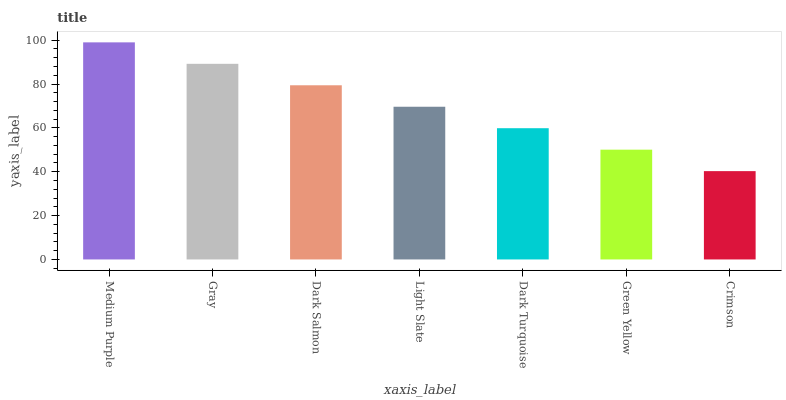Is Crimson the minimum?
Answer yes or no. Yes. Is Medium Purple the maximum?
Answer yes or no. Yes. Is Gray the minimum?
Answer yes or no. No. Is Gray the maximum?
Answer yes or no. No. Is Medium Purple greater than Gray?
Answer yes or no. Yes. Is Gray less than Medium Purple?
Answer yes or no. Yes. Is Gray greater than Medium Purple?
Answer yes or no. No. Is Medium Purple less than Gray?
Answer yes or no. No. Is Light Slate the high median?
Answer yes or no. Yes. Is Light Slate the low median?
Answer yes or no. Yes. Is Crimson the high median?
Answer yes or no. No. Is Medium Purple the low median?
Answer yes or no. No. 